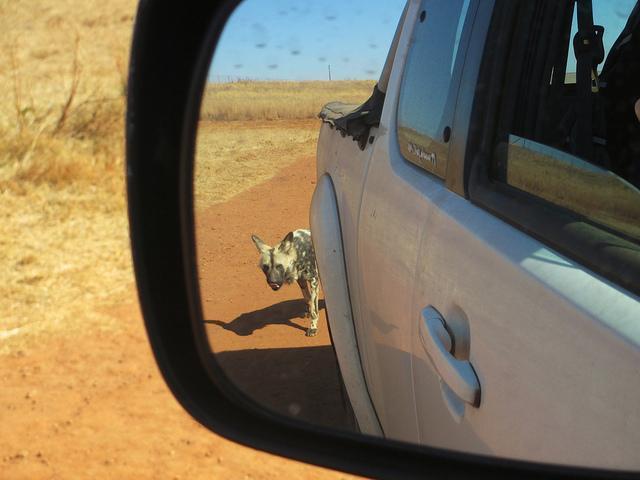How many trucks are there?
Give a very brief answer. 1. 